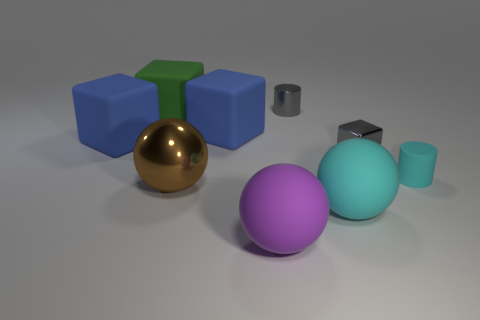Add 1 large green matte cylinders. How many objects exist? 10 Subtract all green cubes. How many cubes are left? 3 Subtract all gray blocks. How many blocks are left? 3 Subtract all spheres. How many objects are left? 6 Subtract 2 balls. How many balls are left? 1 Subtract all purple cylinders. How many blue blocks are left? 2 Add 9 big purple spheres. How many big purple spheres exist? 10 Subtract 0 green cylinders. How many objects are left? 9 Subtract all cyan cylinders. Subtract all green balls. How many cylinders are left? 1 Subtract all red metallic blocks. Subtract all large shiny spheres. How many objects are left? 8 